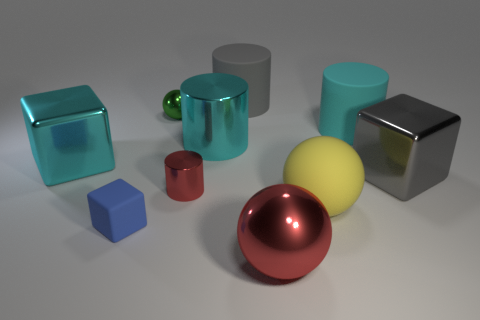Subtract all large metal cubes. How many cubes are left? 1 Subtract 1 cubes. How many cubes are left? 2 Subtract all red spheres. How many spheres are left? 2 Add 6 large yellow shiny cylinders. How many large yellow shiny cylinders exist? 6 Subtract 0 yellow cylinders. How many objects are left? 10 Subtract all cubes. How many objects are left? 7 Subtract all yellow spheres. Subtract all blue cylinders. How many spheres are left? 2 Subtract all blue cylinders. How many purple balls are left? 0 Subtract all green balls. Subtract all red metallic things. How many objects are left? 7 Add 8 big gray cubes. How many big gray cubes are left? 9 